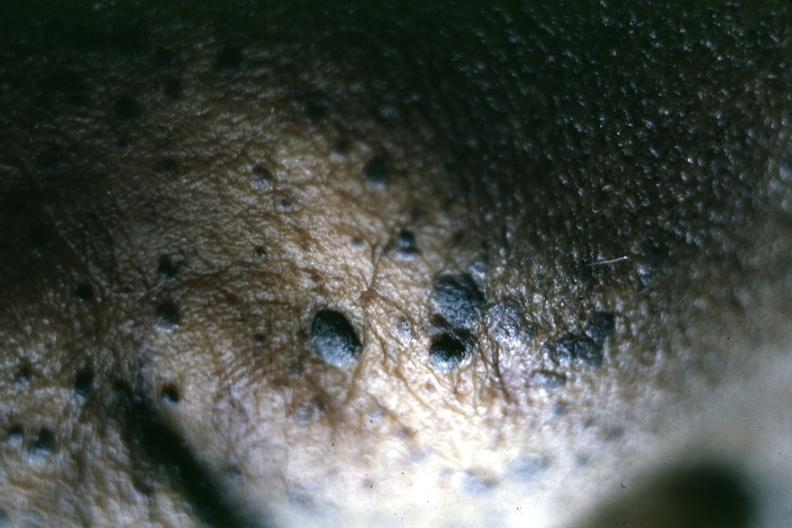what is close-up of typical lesions perspective of elevated pasted on lesions shown?
Answer the question using a single word or phrase. Lesions well 